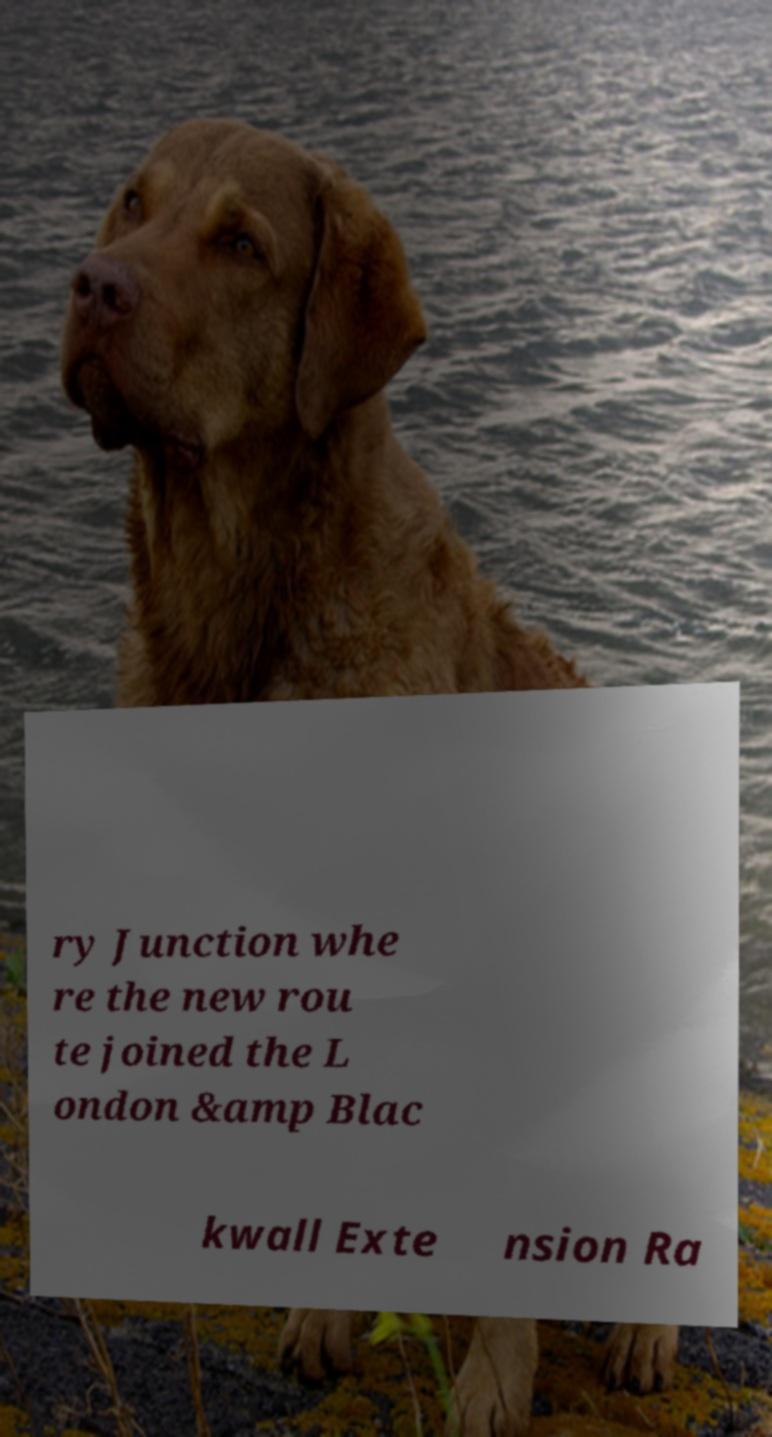There's text embedded in this image that I need extracted. Can you transcribe it verbatim? ry Junction whe re the new rou te joined the L ondon &amp Blac kwall Exte nsion Ra 